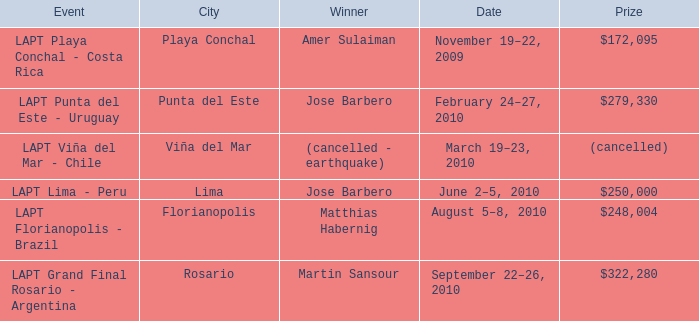What is the date of the event with a $322,280 prize? September 22–26, 2010. Can you give me this table as a dict? {'header': ['Event', 'City', 'Winner', 'Date', 'Prize'], 'rows': [['LAPT Playa Conchal - Costa Rica', 'Playa Conchal', 'Amer Sulaiman', 'November 19–22, 2009', '$172,095'], ['LAPT Punta del Este - Uruguay', 'Punta del Este', 'Jose Barbero', 'February 24–27, 2010', '$279,330'], ['LAPT Viña del Mar - Chile', 'Viña del Mar', '(cancelled - earthquake)', 'March 19–23, 2010', '(cancelled)'], ['LAPT Lima - Peru', 'Lima', 'Jose Barbero', 'June 2–5, 2010', '$250,000'], ['LAPT Florianopolis - Brazil', 'Florianopolis', 'Matthias Habernig', 'August 5–8, 2010', '$248,004'], ['LAPT Grand Final Rosario - Argentina', 'Rosario', 'Martin Sansour', 'September 22–26, 2010', '$322,280']]} 